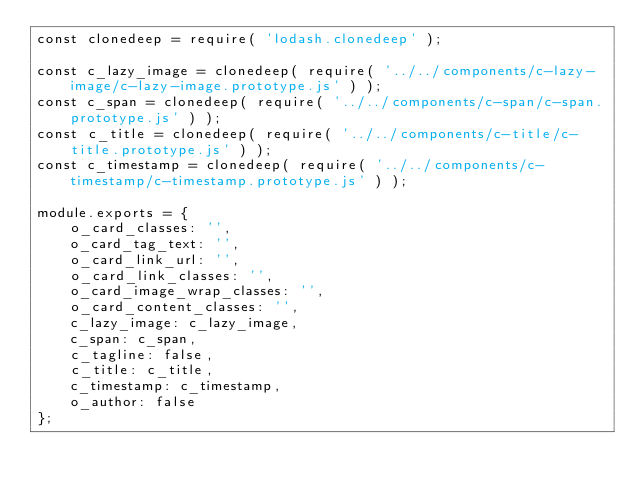Convert code to text. <code><loc_0><loc_0><loc_500><loc_500><_JavaScript_>const clonedeep = require( 'lodash.clonedeep' );

const c_lazy_image = clonedeep( require( '../../components/c-lazy-image/c-lazy-image.prototype.js' ) );
const c_span = clonedeep( require( '../../components/c-span/c-span.prototype.js' ) );
const c_title = clonedeep( require( '../../components/c-title/c-title.prototype.js' ) );
const c_timestamp = clonedeep( require( '../../components/c-timestamp/c-timestamp.prototype.js' ) );

module.exports = {
	o_card_classes: '',
	o_card_tag_text: '',
	o_card_link_url: '',
	o_card_link_classes: '',
	o_card_image_wrap_classes: '',
	o_card_content_classes: '',
	c_lazy_image: c_lazy_image,
	c_span: c_span,
	c_tagline: false,
	c_title: c_title,
	c_timestamp: c_timestamp,
	o_author: false
};
</code> 